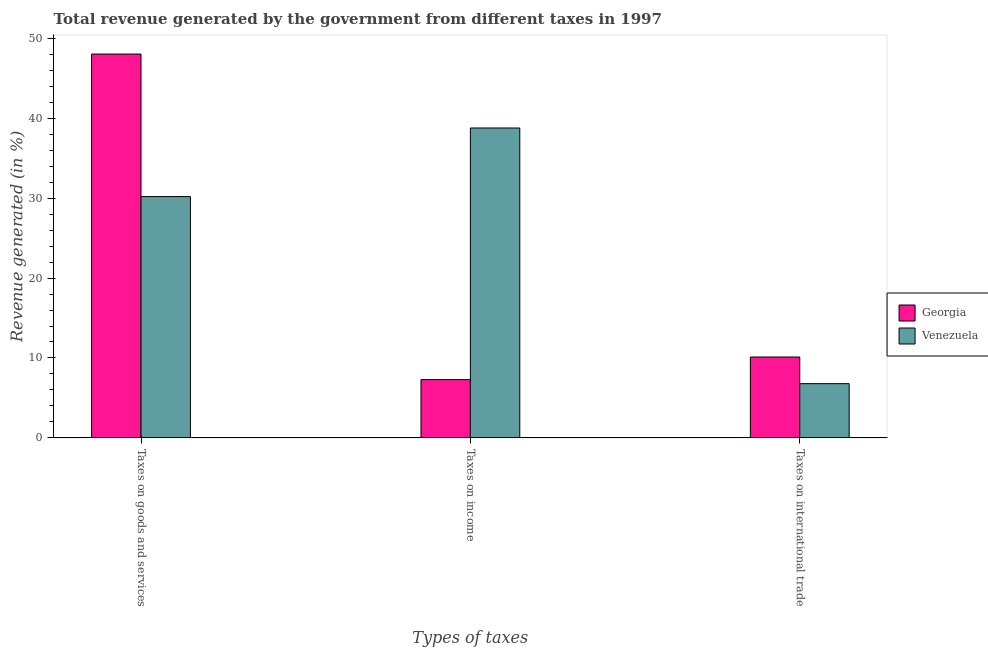How many groups of bars are there?
Your answer should be compact. 3. Are the number of bars per tick equal to the number of legend labels?
Your answer should be compact. Yes. Are the number of bars on each tick of the X-axis equal?
Provide a short and direct response. Yes. What is the label of the 2nd group of bars from the left?
Give a very brief answer. Taxes on income. What is the percentage of revenue generated by taxes on goods and services in Venezuela?
Offer a very short reply. 30.2. Across all countries, what is the maximum percentage of revenue generated by taxes on income?
Offer a very short reply. 38.78. Across all countries, what is the minimum percentage of revenue generated by tax on international trade?
Offer a terse response. 6.79. In which country was the percentage of revenue generated by taxes on goods and services maximum?
Offer a very short reply. Georgia. In which country was the percentage of revenue generated by tax on international trade minimum?
Ensure brevity in your answer.  Venezuela. What is the total percentage of revenue generated by tax on international trade in the graph?
Keep it short and to the point. 16.91. What is the difference between the percentage of revenue generated by tax on international trade in Venezuela and that in Georgia?
Offer a terse response. -3.33. What is the difference between the percentage of revenue generated by taxes on income in Georgia and the percentage of revenue generated by tax on international trade in Venezuela?
Your response must be concise. 0.51. What is the average percentage of revenue generated by taxes on goods and services per country?
Your answer should be very brief. 39.11. What is the difference between the percentage of revenue generated by taxes on goods and services and percentage of revenue generated by taxes on income in Venezuela?
Give a very brief answer. -8.59. What is the ratio of the percentage of revenue generated by taxes on goods and services in Venezuela to that in Georgia?
Provide a short and direct response. 0.63. What is the difference between the highest and the second highest percentage of revenue generated by tax on international trade?
Make the answer very short. 3.33. What is the difference between the highest and the lowest percentage of revenue generated by taxes on goods and services?
Your answer should be very brief. 17.84. In how many countries, is the percentage of revenue generated by tax on international trade greater than the average percentage of revenue generated by tax on international trade taken over all countries?
Give a very brief answer. 1. Is the sum of the percentage of revenue generated by taxes on income in Georgia and Venezuela greater than the maximum percentage of revenue generated by tax on international trade across all countries?
Your response must be concise. Yes. What does the 2nd bar from the left in Taxes on international trade represents?
Your answer should be compact. Venezuela. What does the 1st bar from the right in Taxes on income represents?
Give a very brief answer. Venezuela. Is it the case that in every country, the sum of the percentage of revenue generated by taxes on goods and services and percentage of revenue generated by taxes on income is greater than the percentage of revenue generated by tax on international trade?
Your answer should be very brief. Yes. How many bars are there?
Offer a terse response. 6. What is the difference between two consecutive major ticks on the Y-axis?
Provide a succinct answer. 10. Does the graph contain grids?
Ensure brevity in your answer.  No. How many legend labels are there?
Make the answer very short. 2. What is the title of the graph?
Your response must be concise. Total revenue generated by the government from different taxes in 1997. Does "Iraq" appear as one of the legend labels in the graph?
Give a very brief answer. No. What is the label or title of the X-axis?
Your answer should be compact. Types of taxes. What is the label or title of the Y-axis?
Provide a short and direct response. Revenue generated (in %). What is the Revenue generated (in %) of Georgia in Taxes on goods and services?
Make the answer very short. 48.03. What is the Revenue generated (in %) in Venezuela in Taxes on goods and services?
Make the answer very short. 30.2. What is the Revenue generated (in %) in Georgia in Taxes on income?
Offer a terse response. 7.29. What is the Revenue generated (in %) in Venezuela in Taxes on income?
Provide a succinct answer. 38.78. What is the Revenue generated (in %) of Georgia in Taxes on international trade?
Offer a very short reply. 10.12. What is the Revenue generated (in %) in Venezuela in Taxes on international trade?
Ensure brevity in your answer.  6.79. Across all Types of taxes, what is the maximum Revenue generated (in %) in Georgia?
Offer a terse response. 48.03. Across all Types of taxes, what is the maximum Revenue generated (in %) in Venezuela?
Your answer should be compact. 38.78. Across all Types of taxes, what is the minimum Revenue generated (in %) in Georgia?
Provide a succinct answer. 7.29. Across all Types of taxes, what is the minimum Revenue generated (in %) of Venezuela?
Offer a terse response. 6.79. What is the total Revenue generated (in %) in Georgia in the graph?
Make the answer very short. 65.45. What is the total Revenue generated (in %) of Venezuela in the graph?
Ensure brevity in your answer.  75.76. What is the difference between the Revenue generated (in %) of Georgia in Taxes on goods and services and that in Taxes on income?
Make the answer very short. 40.74. What is the difference between the Revenue generated (in %) in Venezuela in Taxes on goods and services and that in Taxes on income?
Provide a short and direct response. -8.59. What is the difference between the Revenue generated (in %) in Georgia in Taxes on goods and services and that in Taxes on international trade?
Offer a terse response. 37.91. What is the difference between the Revenue generated (in %) of Venezuela in Taxes on goods and services and that in Taxes on international trade?
Ensure brevity in your answer.  23.41. What is the difference between the Revenue generated (in %) of Georgia in Taxes on income and that in Taxes on international trade?
Provide a succinct answer. -2.83. What is the difference between the Revenue generated (in %) in Venezuela in Taxes on income and that in Taxes on international trade?
Make the answer very short. 32. What is the difference between the Revenue generated (in %) of Georgia in Taxes on goods and services and the Revenue generated (in %) of Venezuela in Taxes on income?
Offer a very short reply. 9.25. What is the difference between the Revenue generated (in %) in Georgia in Taxes on goods and services and the Revenue generated (in %) in Venezuela in Taxes on international trade?
Provide a succinct answer. 41.25. What is the difference between the Revenue generated (in %) of Georgia in Taxes on income and the Revenue generated (in %) of Venezuela in Taxes on international trade?
Give a very brief answer. 0.51. What is the average Revenue generated (in %) of Georgia per Types of taxes?
Give a very brief answer. 21.82. What is the average Revenue generated (in %) in Venezuela per Types of taxes?
Keep it short and to the point. 25.25. What is the difference between the Revenue generated (in %) of Georgia and Revenue generated (in %) of Venezuela in Taxes on goods and services?
Your answer should be compact. 17.84. What is the difference between the Revenue generated (in %) of Georgia and Revenue generated (in %) of Venezuela in Taxes on income?
Your answer should be very brief. -31.49. What is the difference between the Revenue generated (in %) in Georgia and Revenue generated (in %) in Venezuela in Taxes on international trade?
Ensure brevity in your answer.  3.33. What is the ratio of the Revenue generated (in %) in Georgia in Taxes on goods and services to that in Taxes on income?
Make the answer very short. 6.59. What is the ratio of the Revenue generated (in %) in Venezuela in Taxes on goods and services to that in Taxes on income?
Ensure brevity in your answer.  0.78. What is the ratio of the Revenue generated (in %) in Georgia in Taxes on goods and services to that in Taxes on international trade?
Your answer should be very brief. 4.75. What is the ratio of the Revenue generated (in %) in Venezuela in Taxes on goods and services to that in Taxes on international trade?
Provide a succinct answer. 4.45. What is the ratio of the Revenue generated (in %) in Georgia in Taxes on income to that in Taxes on international trade?
Your answer should be very brief. 0.72. What is the ratio of the Revenue generated (in %) in Venezuela in Taxes on income to that in Taxes on international trade?
Provide a succinct answer. 5.71. What is the difference between the highest and the second highest Revenue generated (in %) of Georgia?
Offer a terse response. 37.91. What is the difference between the highest and the second highest Revenue generated (in %) of Venezuela?
Keep it short and to the point. 8.59. What is the difference between the highest and the lowest Revenue generated (in %) of Georgia?
Ensure brevity in your answer.  40.74. What is the difference between the highest and the lowest Revenue generated (in %) of Venezuela?
Ensure brevity in your answer.  32. 